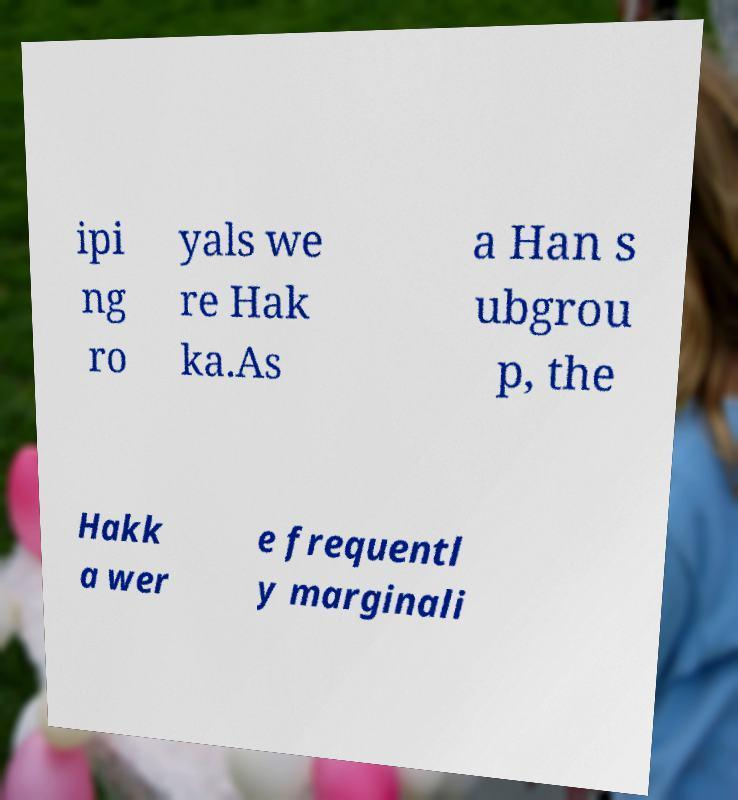Could you assist in decoding the text presented in this image and type it out clearly? ipi ng ro yals we re Hak ka.As a Han s ubgrou p, the Hakk a wer e frequentl y marginali 